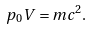<formula> <loc_0><loc_0><loc_500><loc_500>p _ { 0 } V = m c ^ { 2 } .</formula> 